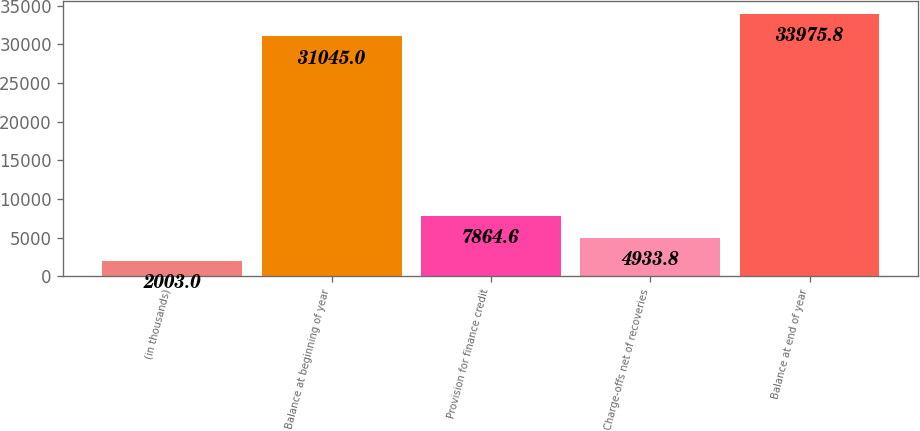<chart> <loc_0><loc_0><loc_500><loc_500><bar_chart><fcel>(in thousands)<fcel>Balance at beginning of year<fcel>Provision for finance credit<fcel>Charge-offs net of recoveries<fcel>Balance at end of year<nl><fcel>2003<fcel>31045<fcel>7864.6<fcel>4933.8<fcel>33975.8<nl></chart> 